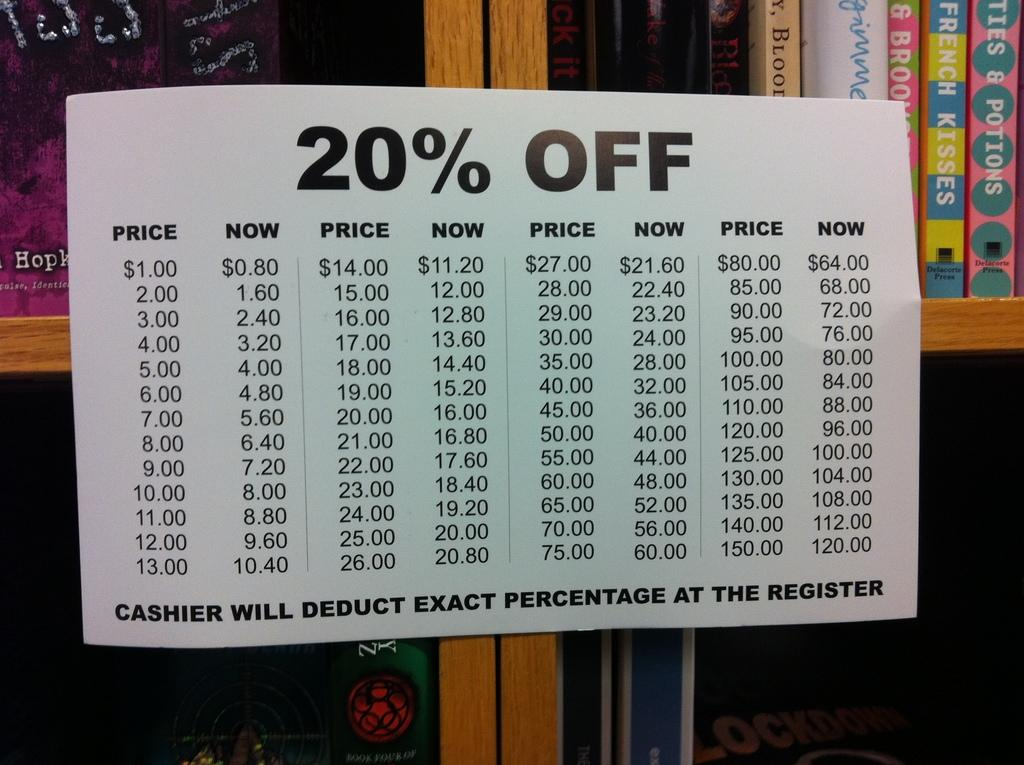<image>
Render a clear and concise summary of the photo. the word off that is on a poster board 